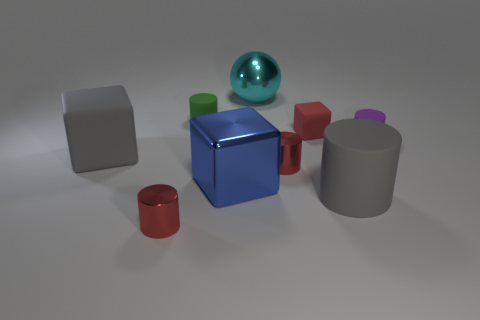Subtract all big cylinders. How many cylinders are left? 4 Subtract 1 balls. How many balls are left? 0 Add 1 tiny gray matte balls. How many objects exist? 10 Subtract all blue cubes. How many cubes are left? 2 Subtract all cubes. How many objects are left? 6 Add 4 gray matte blocks. How many gray matte blocks are left? 5 Add 5 small red rubber things. How many small red rubber things exist? 6 Subtract 1 red cylinders. How many objects are left? 8 Subtract all brown blocks. Subtract all brown cylinders. How many blocks are left? 3 Subtract all gray cylinders. How many red cubes are left? 1 